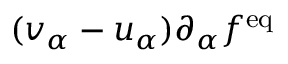Convert formula to latex. <formula><loc_0><loc_0><loc_500><loc_500>( v _ { \alpha } - u _ { \alpha } ) \partial _ { \alpha } f ^ { e q }</formula> 